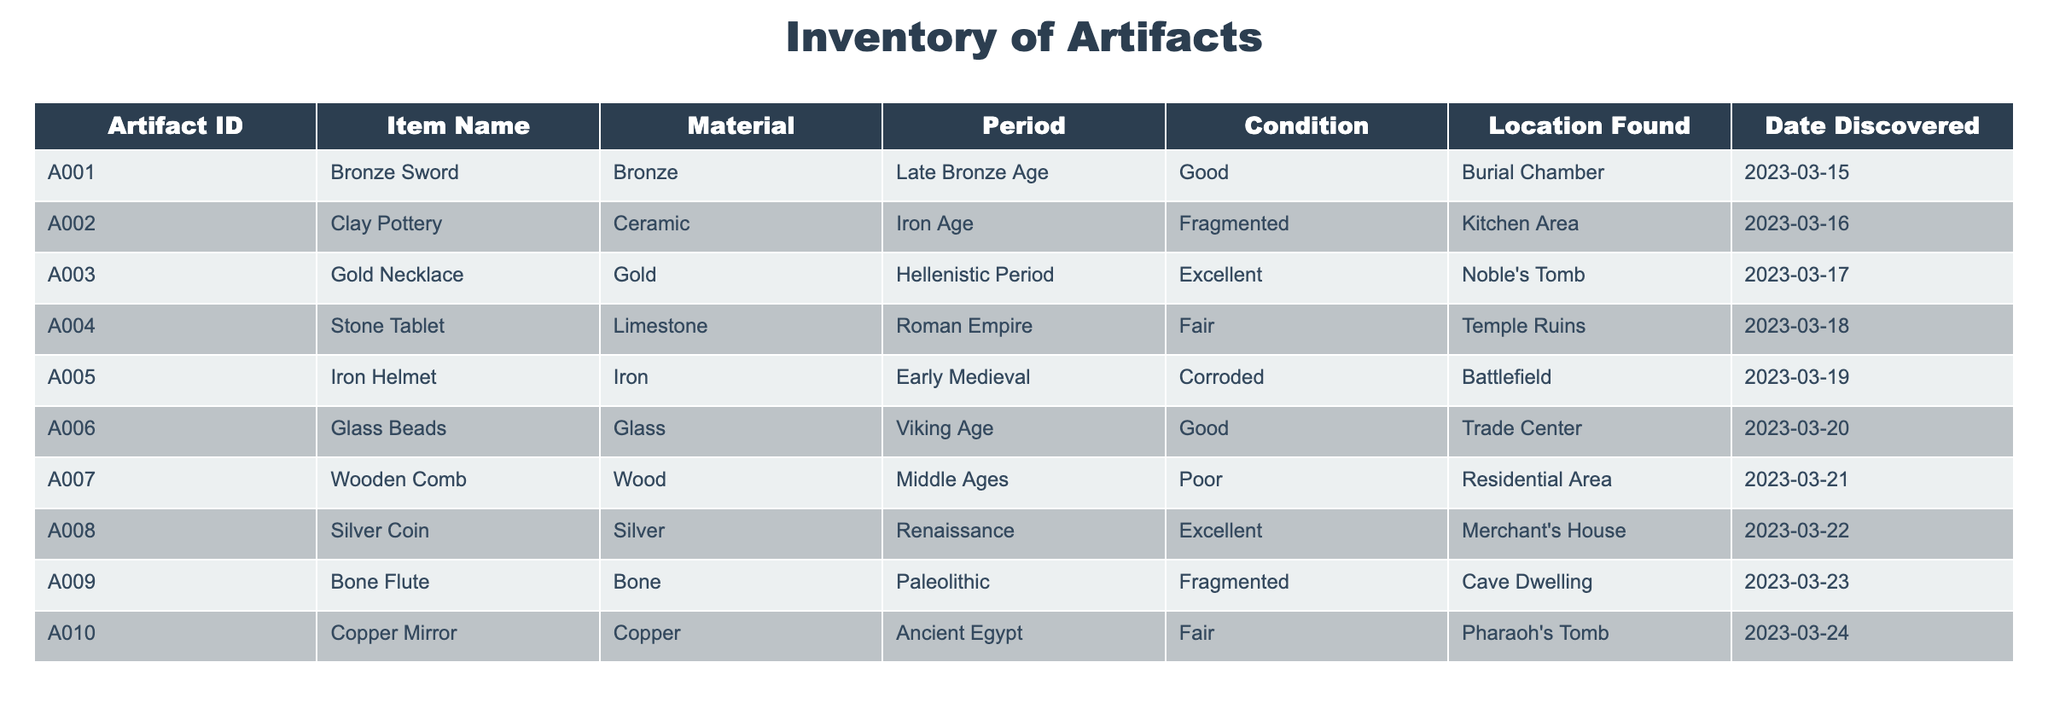What is the material of the artifact with ID A003? The table lists the artifact with ID A003 as a Gold Necklace, which is made of Gold.
Answer: Gold How many artifacts were found in the Kitchen Area? The table shows one artifact found in the Kitchen Area, which is the Clay Pottery with ID A002.
Answer: 1 Is the Iron Helmet in good condition? The Iron Helmet is listed in the table as being Corroded, which means it is not in good condition.
Answer: No What is the total number of artifacts made of metal? There are four metal artifacts: Bronze Sword, Iron Helmet, Silver Coin, and Copper Mirror. Adding them gives us a total of 4.
Answer: 4 Which artifact was discovered most recently? The most recent discovery listed in the table is the Iron Helmet, discovered on March 19, 2023.
Answer: Iron Helmet Are there any artifacts found in a Residential Area? Yes, the Wooden Comb was found in the Residential Area as mentioned in the table.
Answer: Yes What is the difference in condition between the Gold Necklace and the Silver Coin? The Gold Necklace is in Excellent condition while the Silver Coin is also in Excellent condition, so there is no difference.
Answer: None How many artifacts belong to the Roman Empire period? The table lists one artifact from the Roman Empire period, which is the Stone Tablet with ID A004.
Answer: 1 What percentage of the artifacts found are in fair condition? From the table, there are 3 artifacts in fair condition (Stone Tablet, Copper Mirror, Iron Helmet) out of a total of 10. The percentage is (3/10) * 100 = 30%.
Answer: 30% 